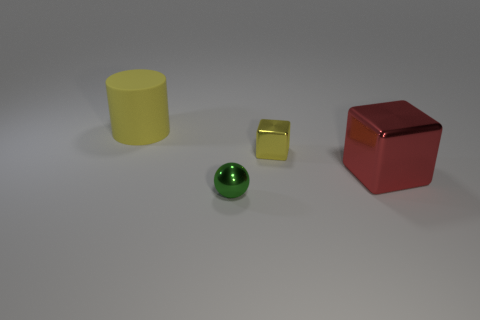There is a shiny thing that is the same color as the big rubber cylinder; what is its size?
Offer a very short reply. Small. How many matte things are either tiny cyan cylinders or large cylinders?
Ensure brevity in your answer.  1. Is there a large yellow object in front of the big rubber thing on the left side of the yellow object that is on the right side of the tiny green thing?
Make the answer very short. No. How many small objects are behind the yellow metal block?
Your response must be concise. 0. There is another object that is the same color as the matte thing; what is it made of?
Offer a terse response. Metal. How many small objects are yellow objects or yellow rubber spheres?
Give a very brief answer. 1. The thing in front of the large metal object has what shape?
Ensure brevity in your answer.  Sphere. Is there a tiny metal object of the same color as the tiny cube?
Give a very brief answer. No. There is a yellow object that is to the right of the tiny sphere; does it have the same size as the object that is in front of the red shiny cube?
Your answer should be very brief. Yes. Is the number of tiny green spheres that are behind the large yellow matte cylinder greater than the number of small things on the right side of the small green object?
Your response must be concise. No. 